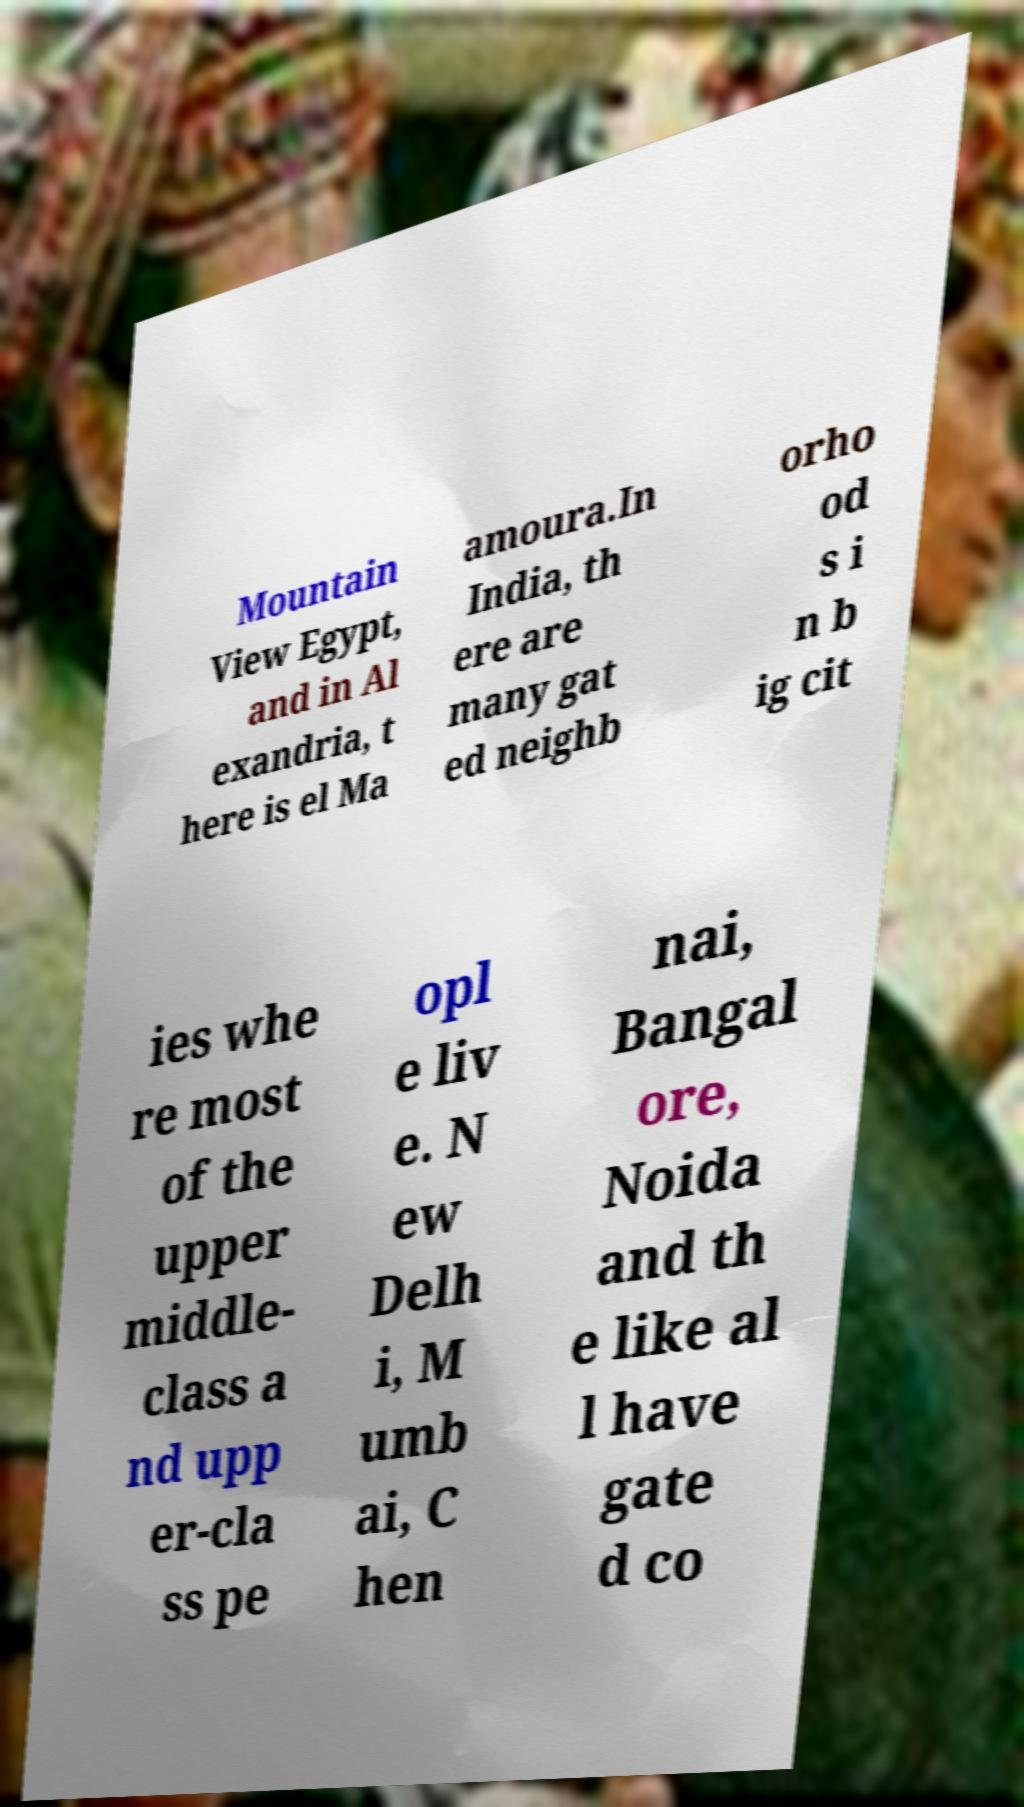There's text embedded in this image that I need extracted. Can you transcribe it verbatim? Mountain View Egypt, and in Al exandria, t here is el Ma amoura.In India, th ere are many gat ed neighb orho od s i n b ig cit ies whe re most of the upper middle- class a nd upp er-cla ss pe opl e liv e. N ew Delh i, M umb ai, C hen nai, Bangal ore, Noida and th e like al l have gate d co 